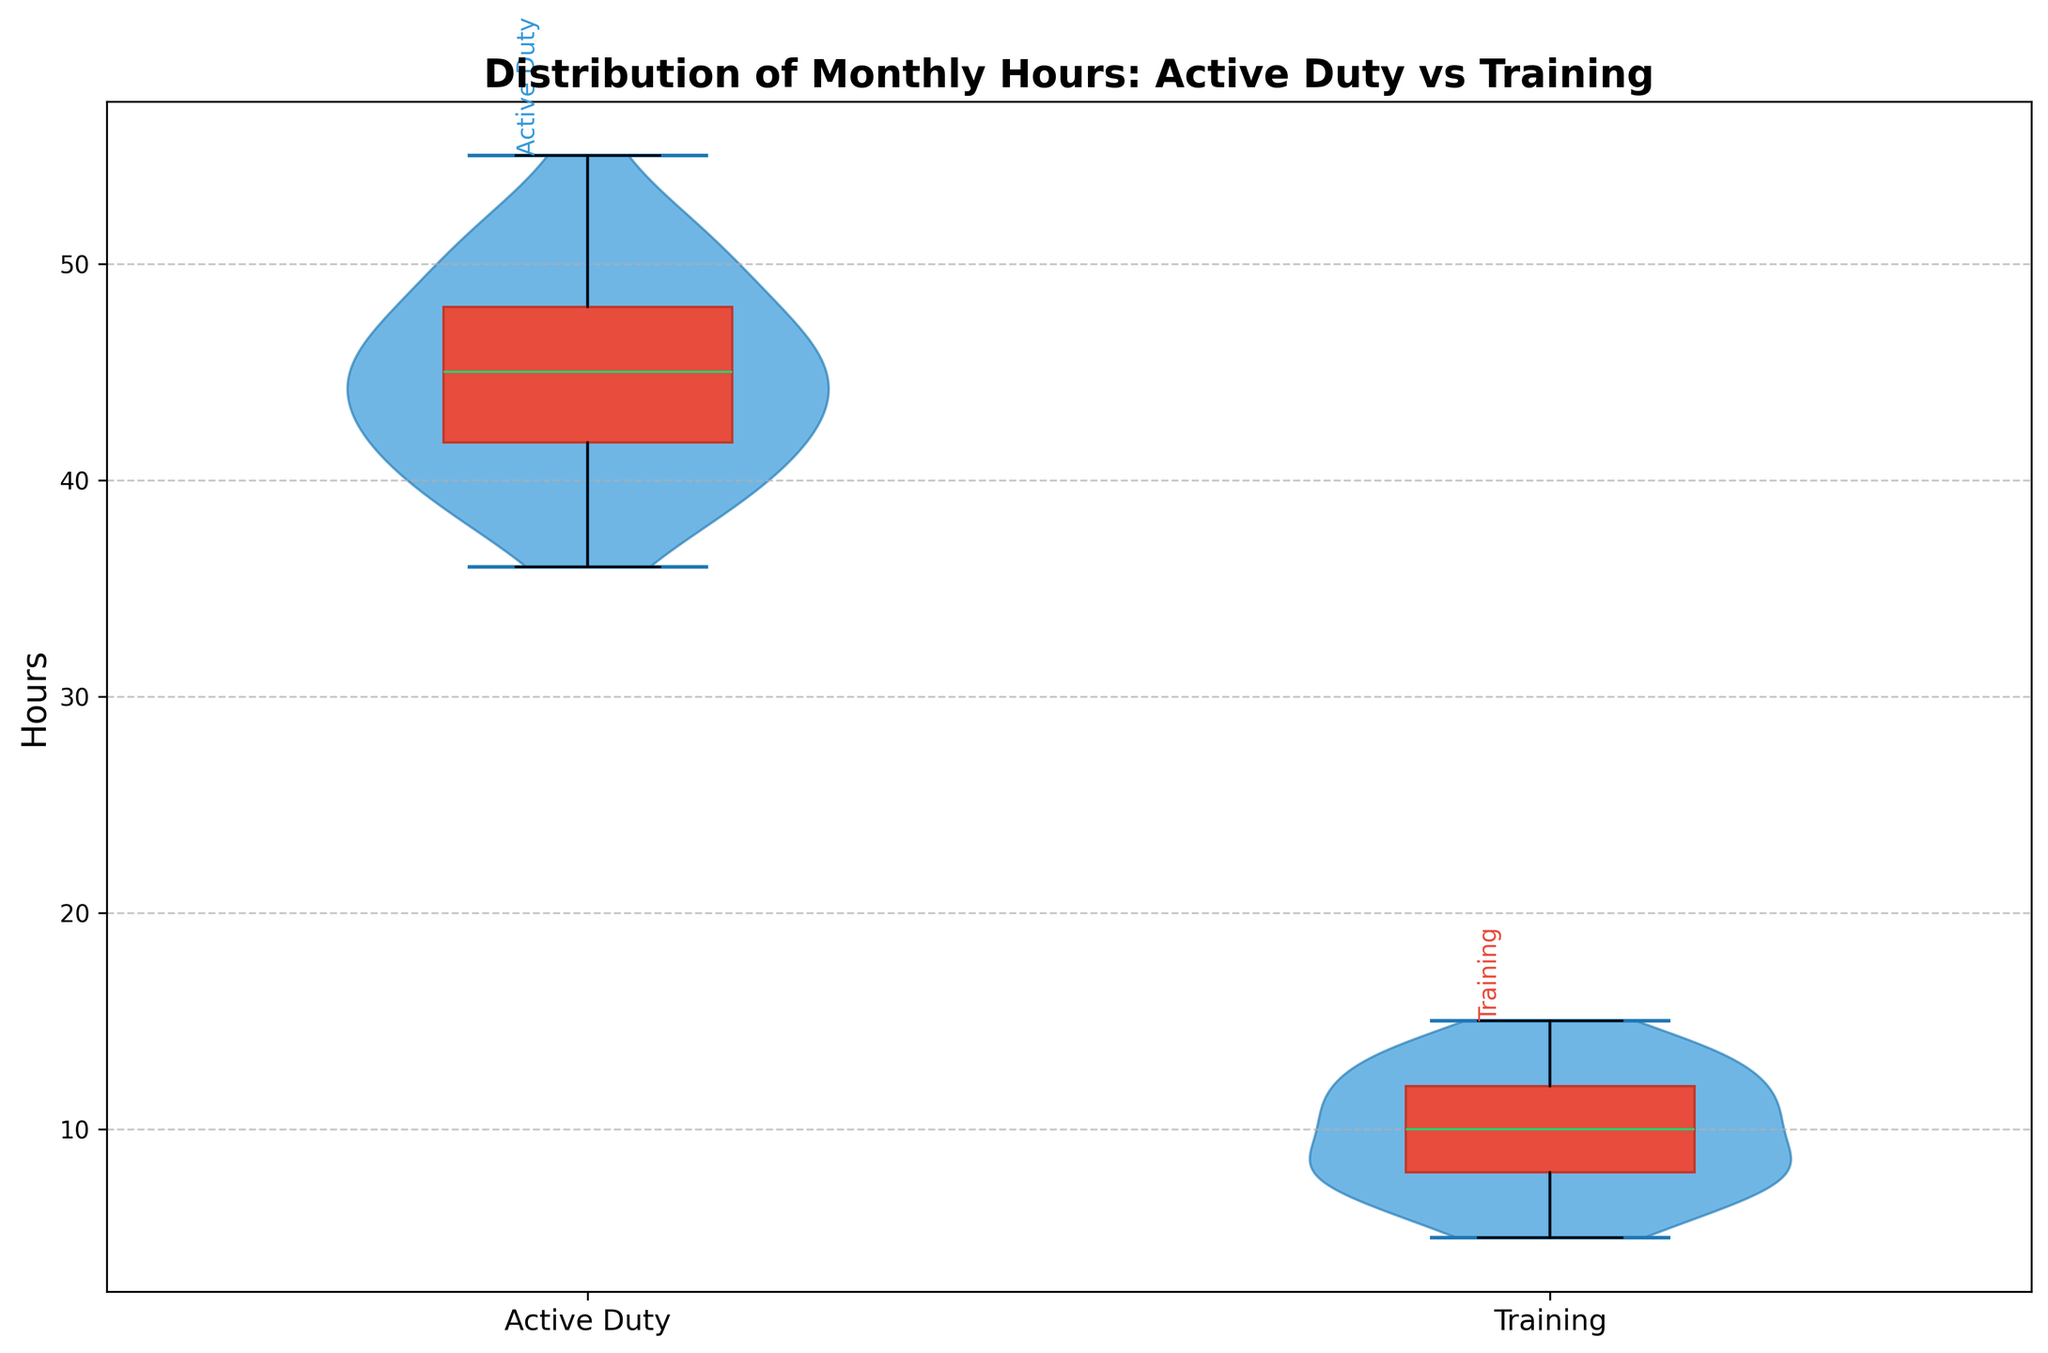What is the title of the figure? The title is usually located at the top of the figure. Since the title in the code is 'Distribution of Monthly Hours: Active Duty vs Training', we refer to that.
Answer: Distribution of Monthly Hours: Active Duty vs Training How many groups are compared in the violin plot? The x-axis labels indicate the groups being compared. Here, the x-axis shows two labels: 'Active Duty' and 'Training'.
Answer: Two What does the y-axis represent? The y-axis label indicates the measure being compared. In this figure, the label 'Hours' shows that it's measuring hours.
Answer: Hours Which group has a higher range of hours? By observing the spread of each violin, we notice that the range of hours for 'Active Duty' is higher, extending from around 36 to 55 hours, whereas 'Training' ranges from around 5 to 15 hours.
Answer: Active Duty Which group has less variability in hours? Variability can be seen in the spread of the data in each violin. The 'Training' group has a narrower spread compared to 'Active Duty'.
Answer: Training What is the median of hours spent in training? The violin plot includes box plots inside. The median is represented by the horizontal line in the box inside the violin. The median for 'Training' appears to be around 12 hours.
Answer: Around 12 hours Between 'Active Duty' and 'Training', which one has a more concentrated distribution? Concentration can be visualized by how tightly packed the data points are. 'Training' has a more concentrated distribution, as its violin shape is thinner compared to 'Active Duty'.
Answer: Training What can we deduce about the shape of the 'Active Duty' distribution? By observing the violin shape for 'Active Duty', the distribution looks approximately symmetrical with some spread in the middle range (40-50 hours).
Answer: Approximately symmetrical What is the mean hours spent on active duty? The mean can be inferred from the central location of the distribution in a violin plot, here it looks to center around 45 hours.
Answer: Around 45 hours Are there any indications of outliers in either group? Outliers would show as points outside the main body of the violin or box plot. Based on the provided plot, there do not appear to be discernible outliers in either group.
Answer: No 